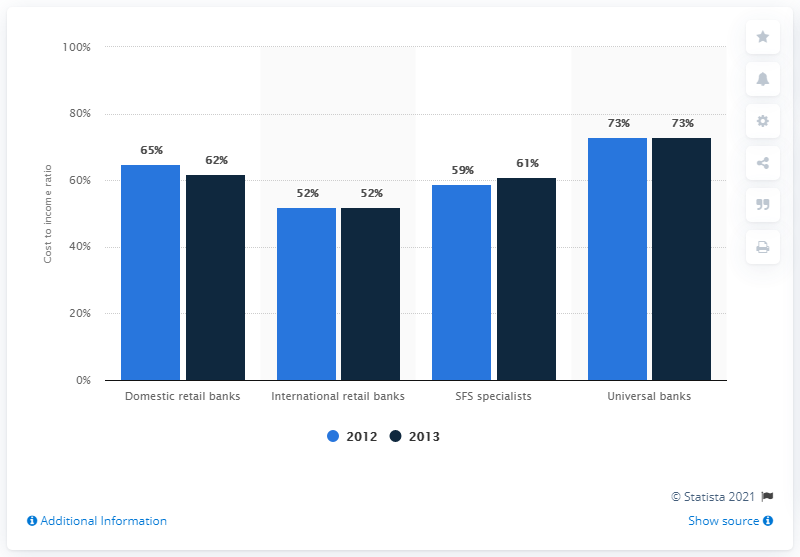Mention a couple of crucial points in this snapshot. The sum total cost-income ratio of domestic retail banks and international retail banks in the year 2013 was approximately 114%. Universal banks had the highest cost-income ratio among European banks in the year 2012. 